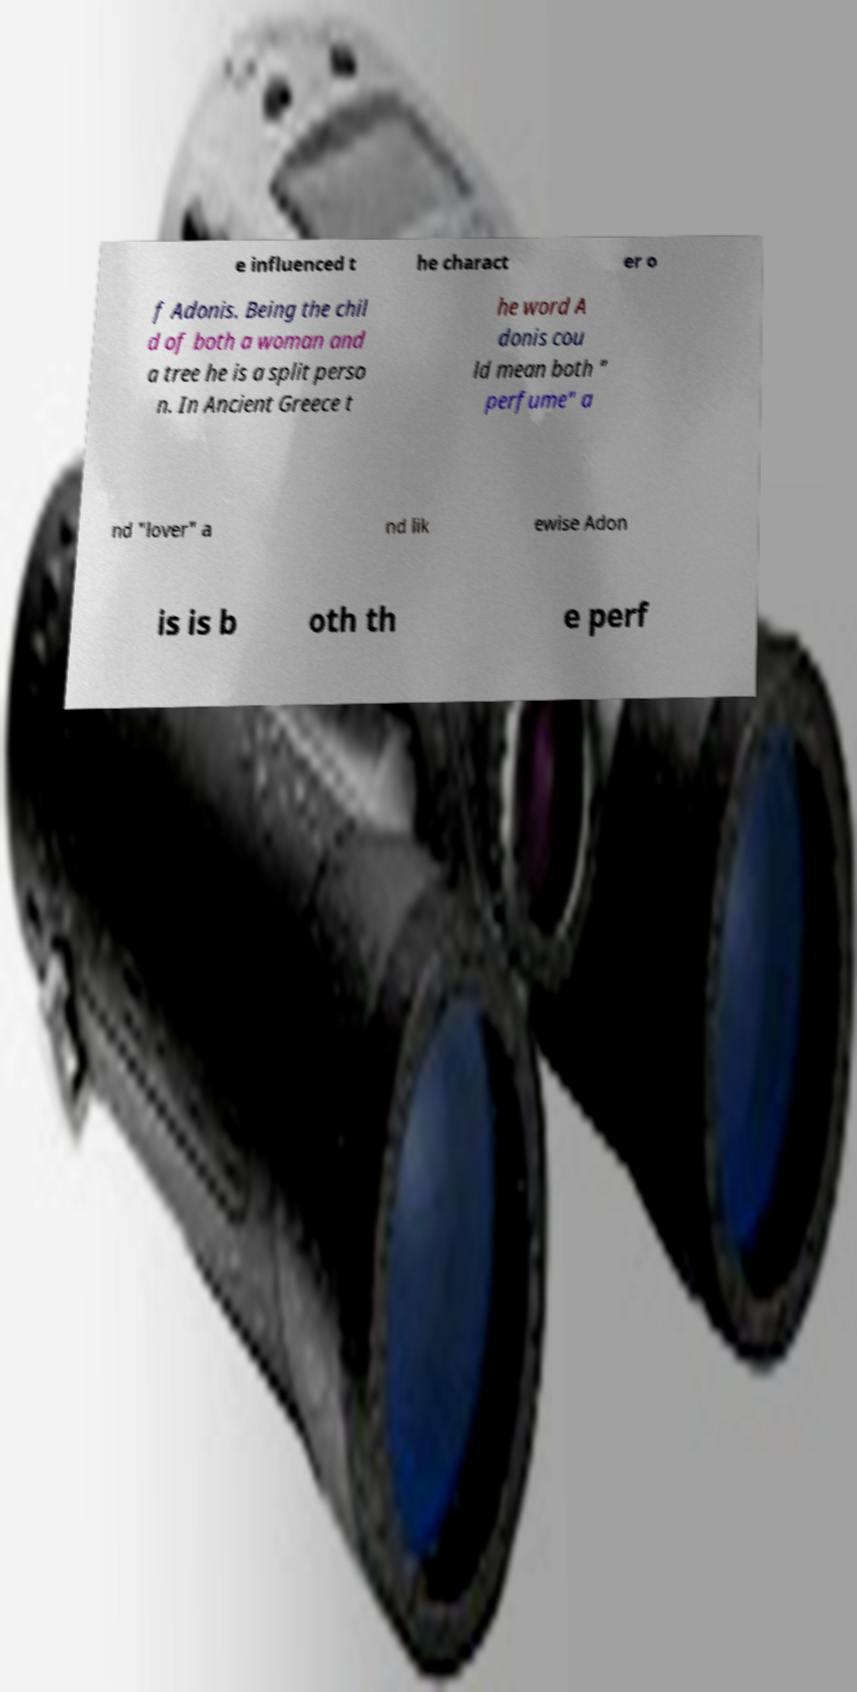Could you extract and type out the text from this image? e influenced t he charact er o f Adonis. Being the chil d of both a woman and a tree he is a split perso n. In Ancient Greece t he word A donis cou ld mean both " perfume" a nd "lover" a nd lik ewise Adon is is b oth th e perf 